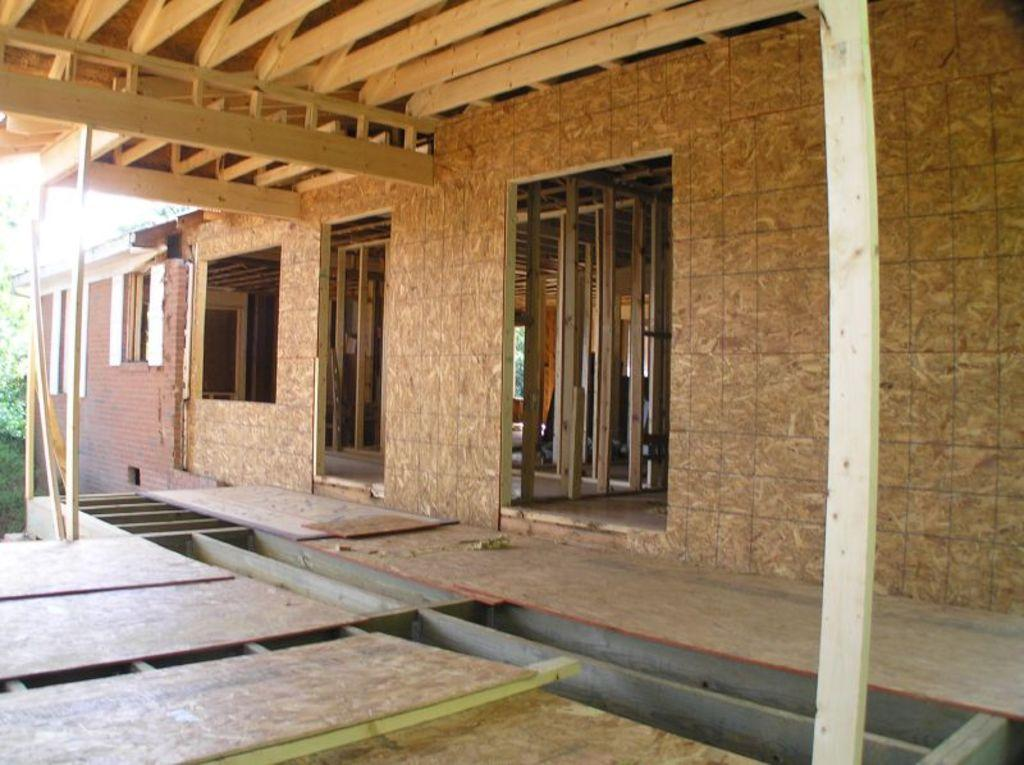What type of structure is present in the image? There is a house in the image. What are the walls made of in the image? The walls are visible in the image. What material is used for the objects in the image? There are wooden objects in the image. What can be seen in the background of the image? There are leaves in the background of the image. Where is the square located in the image? There is no square present in the image. What type of map can be seen in the image? There is no map present in the image. 